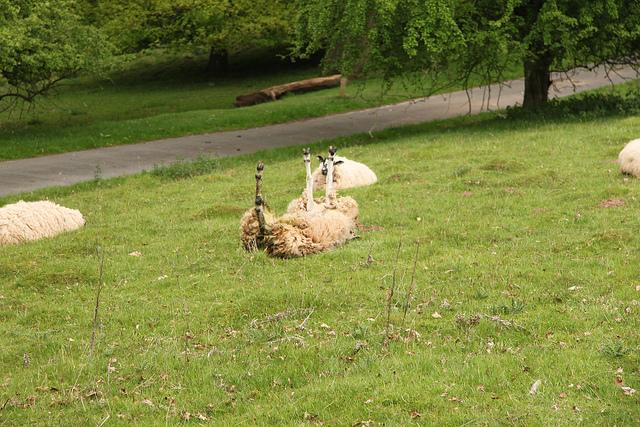What type of animal is this?
Keep it brief. Sheep. Are the animals walking around?
Answer briefly. No. Are the many animals?
Quick response, please. Yes. Is this a rural photo?
Be succinct. Yes. 